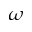Convert formula to latex. <formula><loc_0><loc_0><loc_500><loc_500>\omega</formula> 